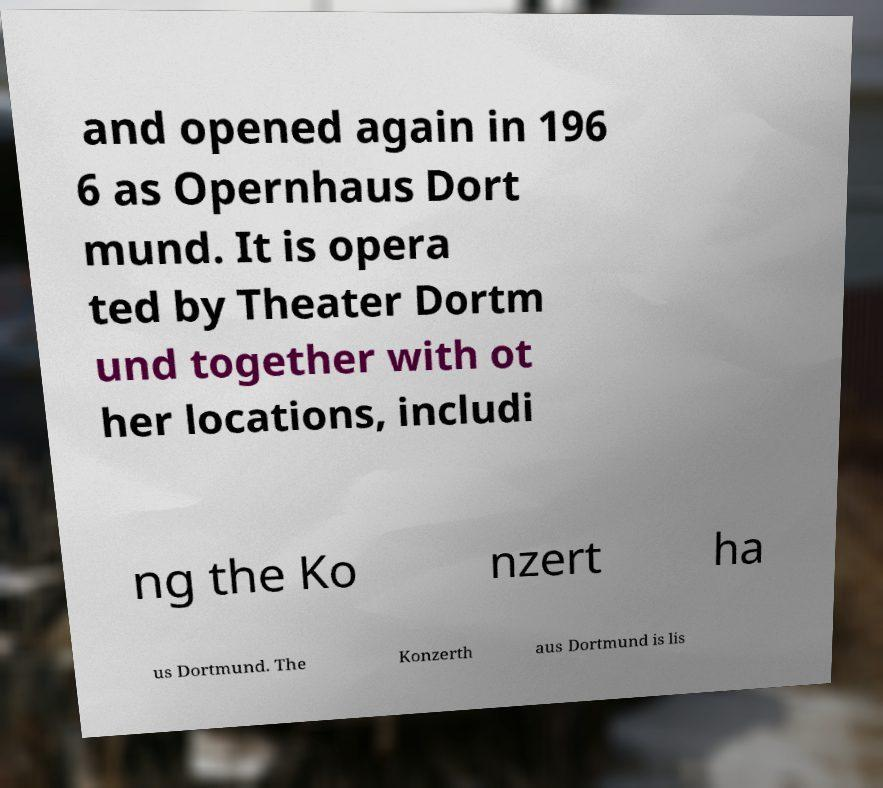Could you assist in decoding the text presented in this image and type it out clearly? and opened again in 196 6 as Opernhaus Dort mund. It is opera ted by Theater Dortm und together with ot her locations, includi ng the Ko nzert ha us Dortmund. The Konzerth aus Dortmund is lis 